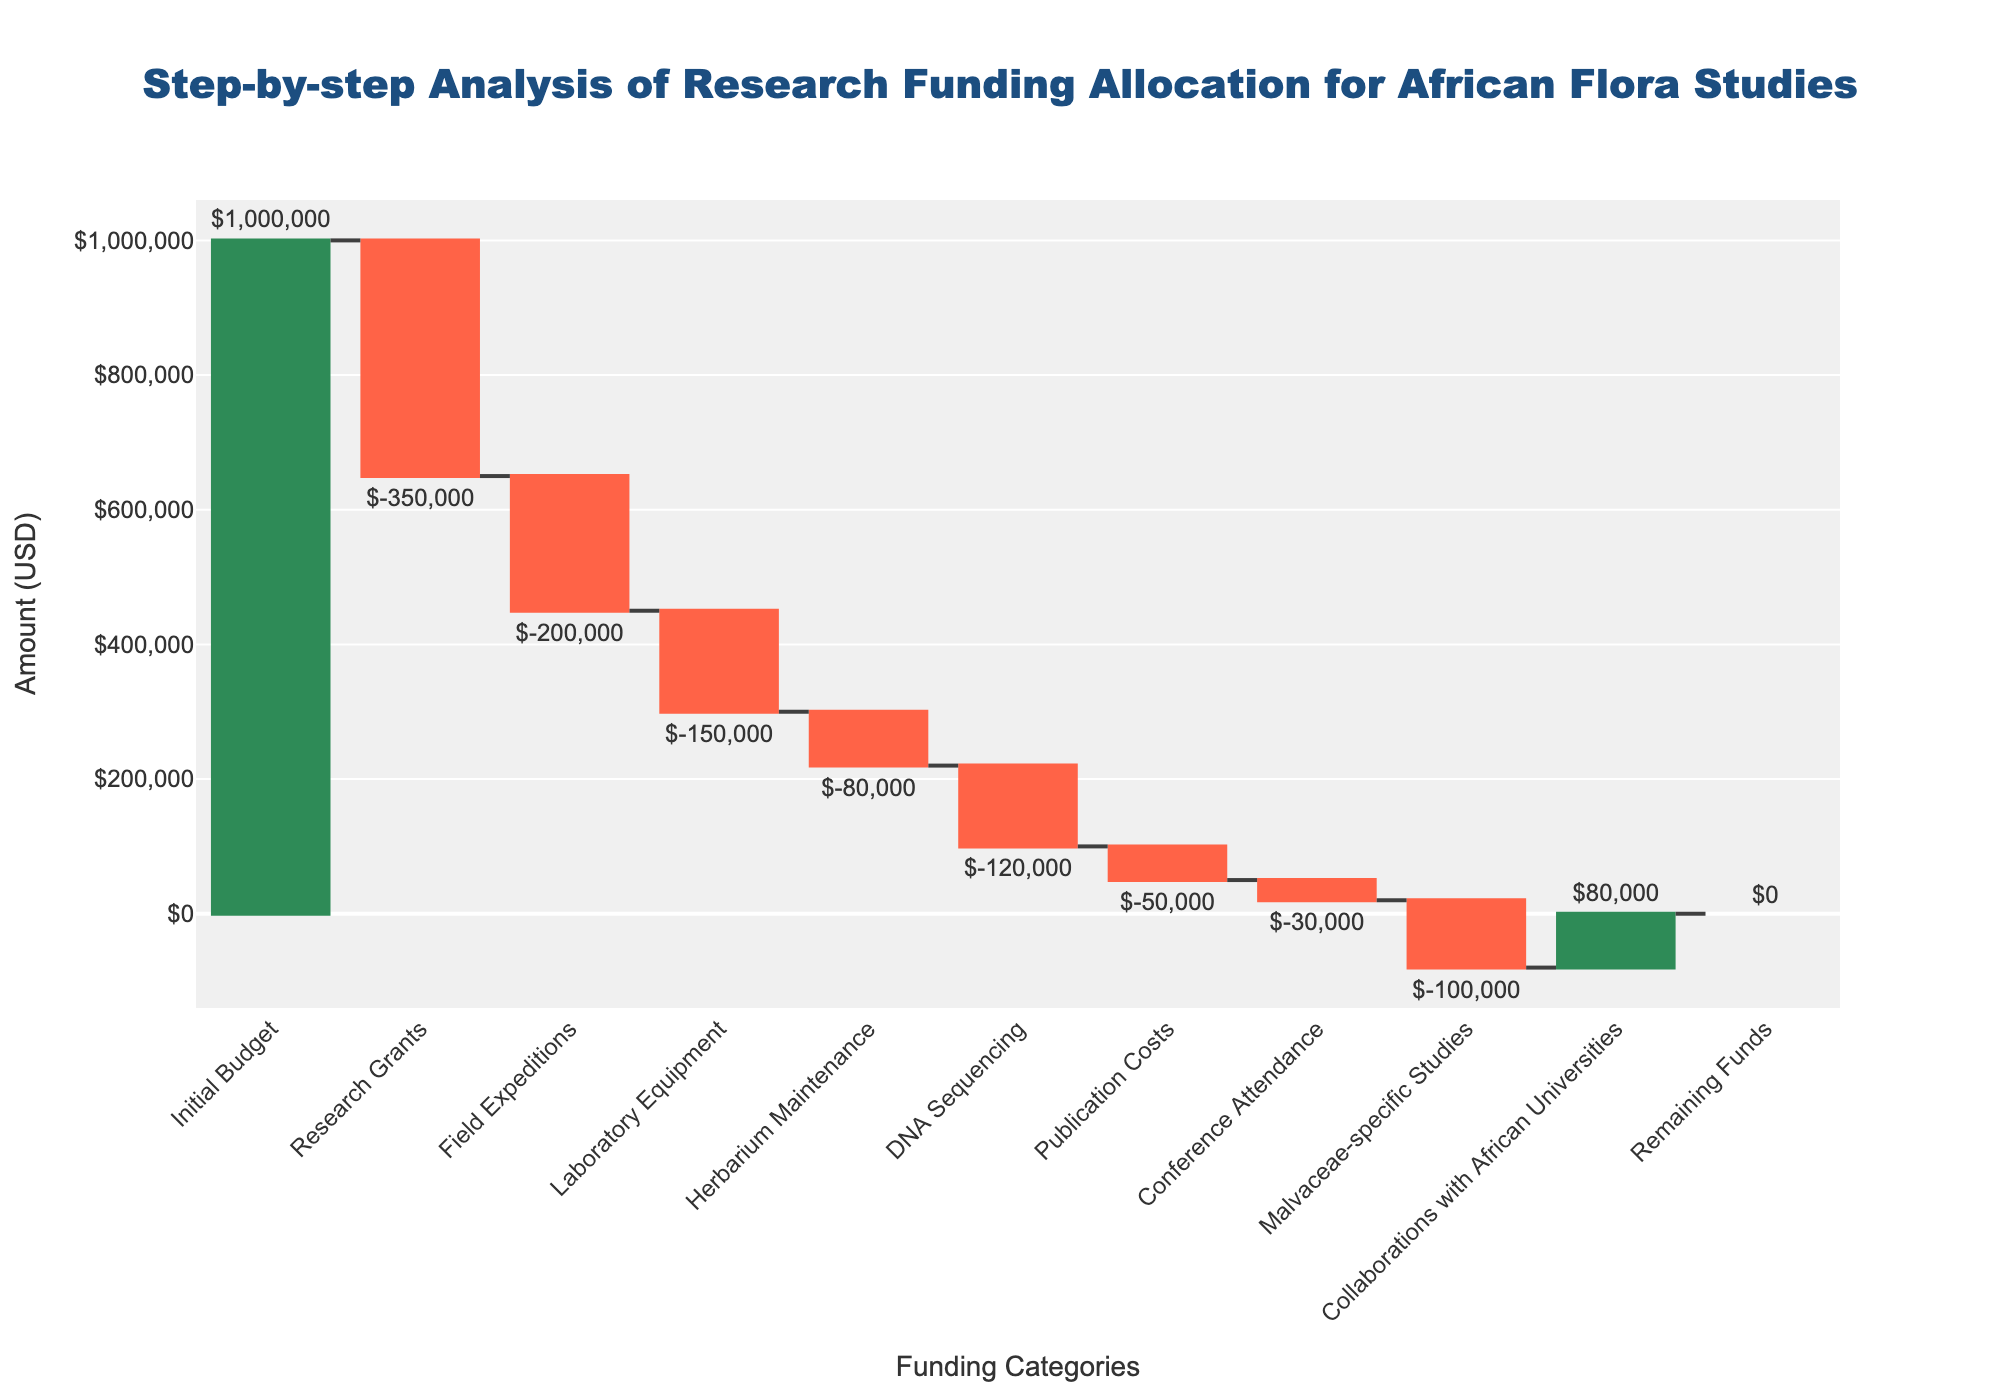what is the initial budget for African flora studies? The initial budget for African flora studies can be found in the first category of the waterfall chart, labeled "Initial Budget", with a value of $1,000,000.
Answer: $1,000,000 How much funding was allocated specifically for Malvaceae-specific Studies? The value for Malvaceae-specific Studies can be found directly in the chart. It is labeled and highlights the amount allocated, which is $100,000.
Answer: $100,000 What is the total amount spent on all activities other than Malvaceae-specific studies? To find the total amount spent on all activities other than Malvaceae-specific studies, add the values of all categories except "Malvaceae-specific Studies": -350000 + -200000 + -150000 + -80000 + -120000 + -50000 + -30000 = -980000.
Answer: -$980,000 Which category resulted in the largest decrease in funds and by how much? To find the category with the largest decrease, identify the bar with the longest downward change (negative value). The Research Grants category shows the largest decrease, with a value of $350,000.
Answer: Research Grants, $350,000 How are the remaining funds described in the chart? The remaining funds are represented by the final bar, categorized as "Remaining Funds," and it has a value of $0. The color of this final bar is also different from the others, indicating it is the total remaining amount.
Answer: The remaining funds are $0 What is the combined spending on Field Expeditions and Laboratory Equipment? The combined spending on Field Expeditions and Laboratory Equipment can be obtained by adding their values: -200000 + -150000 = -350000.
Answer: -$350,000 How does the expenditure on Collaborations with African Universities compare to the amount spent on Publication Costs? Compare the values given for "Collaborations with African Universities" and "Publication Costs". Collaborations with African Universities show a positive value of $80,000, whereas Publication Costs is a negative value of -$50,000. Thus, Collaborations received $130,000 more.
Answer: $130,000 more Which category received a positive allocation of funds? Check the bars in the waterfall chart for positive values. The only category with a positive allocation is "Collaborations with African Universities" with $80,000.
Answer: Collaborations with African Universities What is the total amount allocated for DNA Sequencing and Publication Costs? To find the total, add the amounts for DNA Sequencing and Publication Costs: -120000 + -50000 = -170000.
Answer: -$170,000 Which funding category had the smallest impact on the budget, and what was the amount? Find the bar with the smallest absolute value. The smallest impact on the budget came from Conference Attendance, which had a value of -$30,000.
Answer: Conference Attendance, -$30,000 